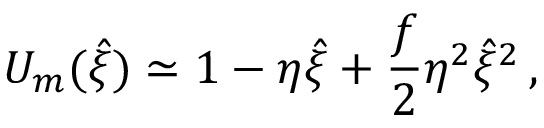<formula> <loc_0><loc_0><loc_500><loc_500>U _ { m } ( \hat { \xi } ) \simeq 1 - \eta \hat { \xi } + \frac { f } { 2 } \eta ^ { 2 } \hat { \xi } ^ { 2 } \, ,</formula> 